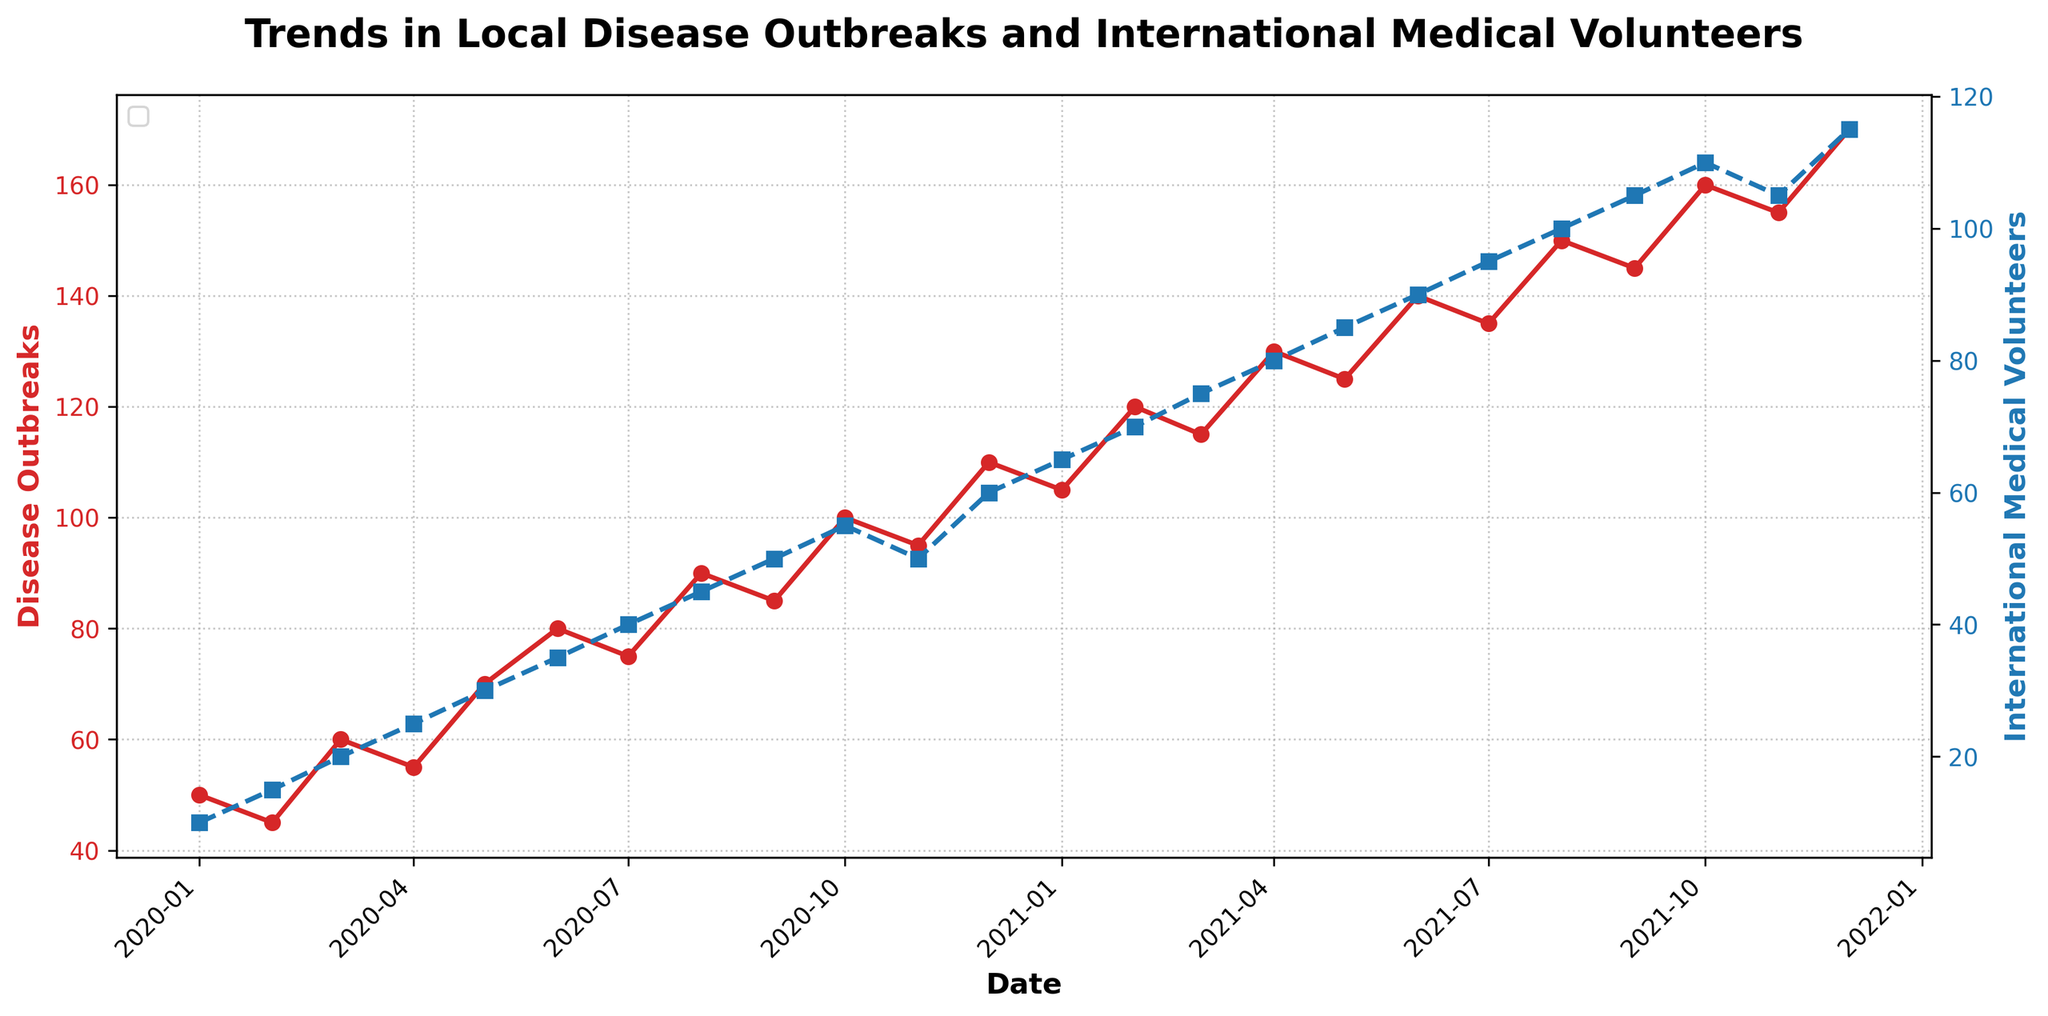What's the title of the figure? The title of the figure is displayed at the top, and it is "Trends in Local Disease Outbreaks and International Medical Volunteers."
Answer: Trends in Local Disease Outbreaks and International Medical Volunteers What does the red line represent? The red line represents the number of disease outbreaks over time. This can be seen from the y-axis labeled "Disease Outbreaks" and the color of the line.
Answer: Disease outbreaks How many international medical volunteers were there in August 2021? Locate the point corresponding to August 2021 along the x-axis, then follow the blue dashed line upwards to its value on the right y-axis labeled "International Medical Volunteers".
Answer: 100 What trend can be observed about disease outbreaks from January 2020 to December 2021? Over the time period, the number of disease outbreaks generally increases, as indicated by the upward trend in the red line.
Answer: Increasing Which month had the maximum number of disease outbreaks? Identify the highest point on the red line and find the corresponding date on the x-axis. This highest point occurs in December 2021.
Answer: December 2021 Is there a general correlation between the number of disease outbreaks and the arrival of international medical volunteers? Both lines show an upward trend, suggesting a positive correlation between the number of disease outbreaks and the arrival of international medical volunteers.
Answer: Yes How many disease outbreaks were there in January 2021 compared to January 2020? Compare the y-values of the red line for January 2021 and January 2020. In January 2021, there were 105 outbreaks, compared to 50 in January 2020.
Answer: January 2021 had 55 more outbreaks than January 2020 Did the number of international medical volunteers ever decrease, and if so, when? Look for any downward trend in the blue dashed line. A decrease is observed in November 2021 to 105 volunteers from 110 in October 2021.
Answer: November 2021 What is the rate of increase in disease outbreaks from May 2021 to June 2021? Calculate the difference between the values in May 2021 and June 2021. In May 2021, there were 125 outbreaks, which increased to 140 in June 2021. The rate of increase is 140 - 125 = 15.
Answer: 15 